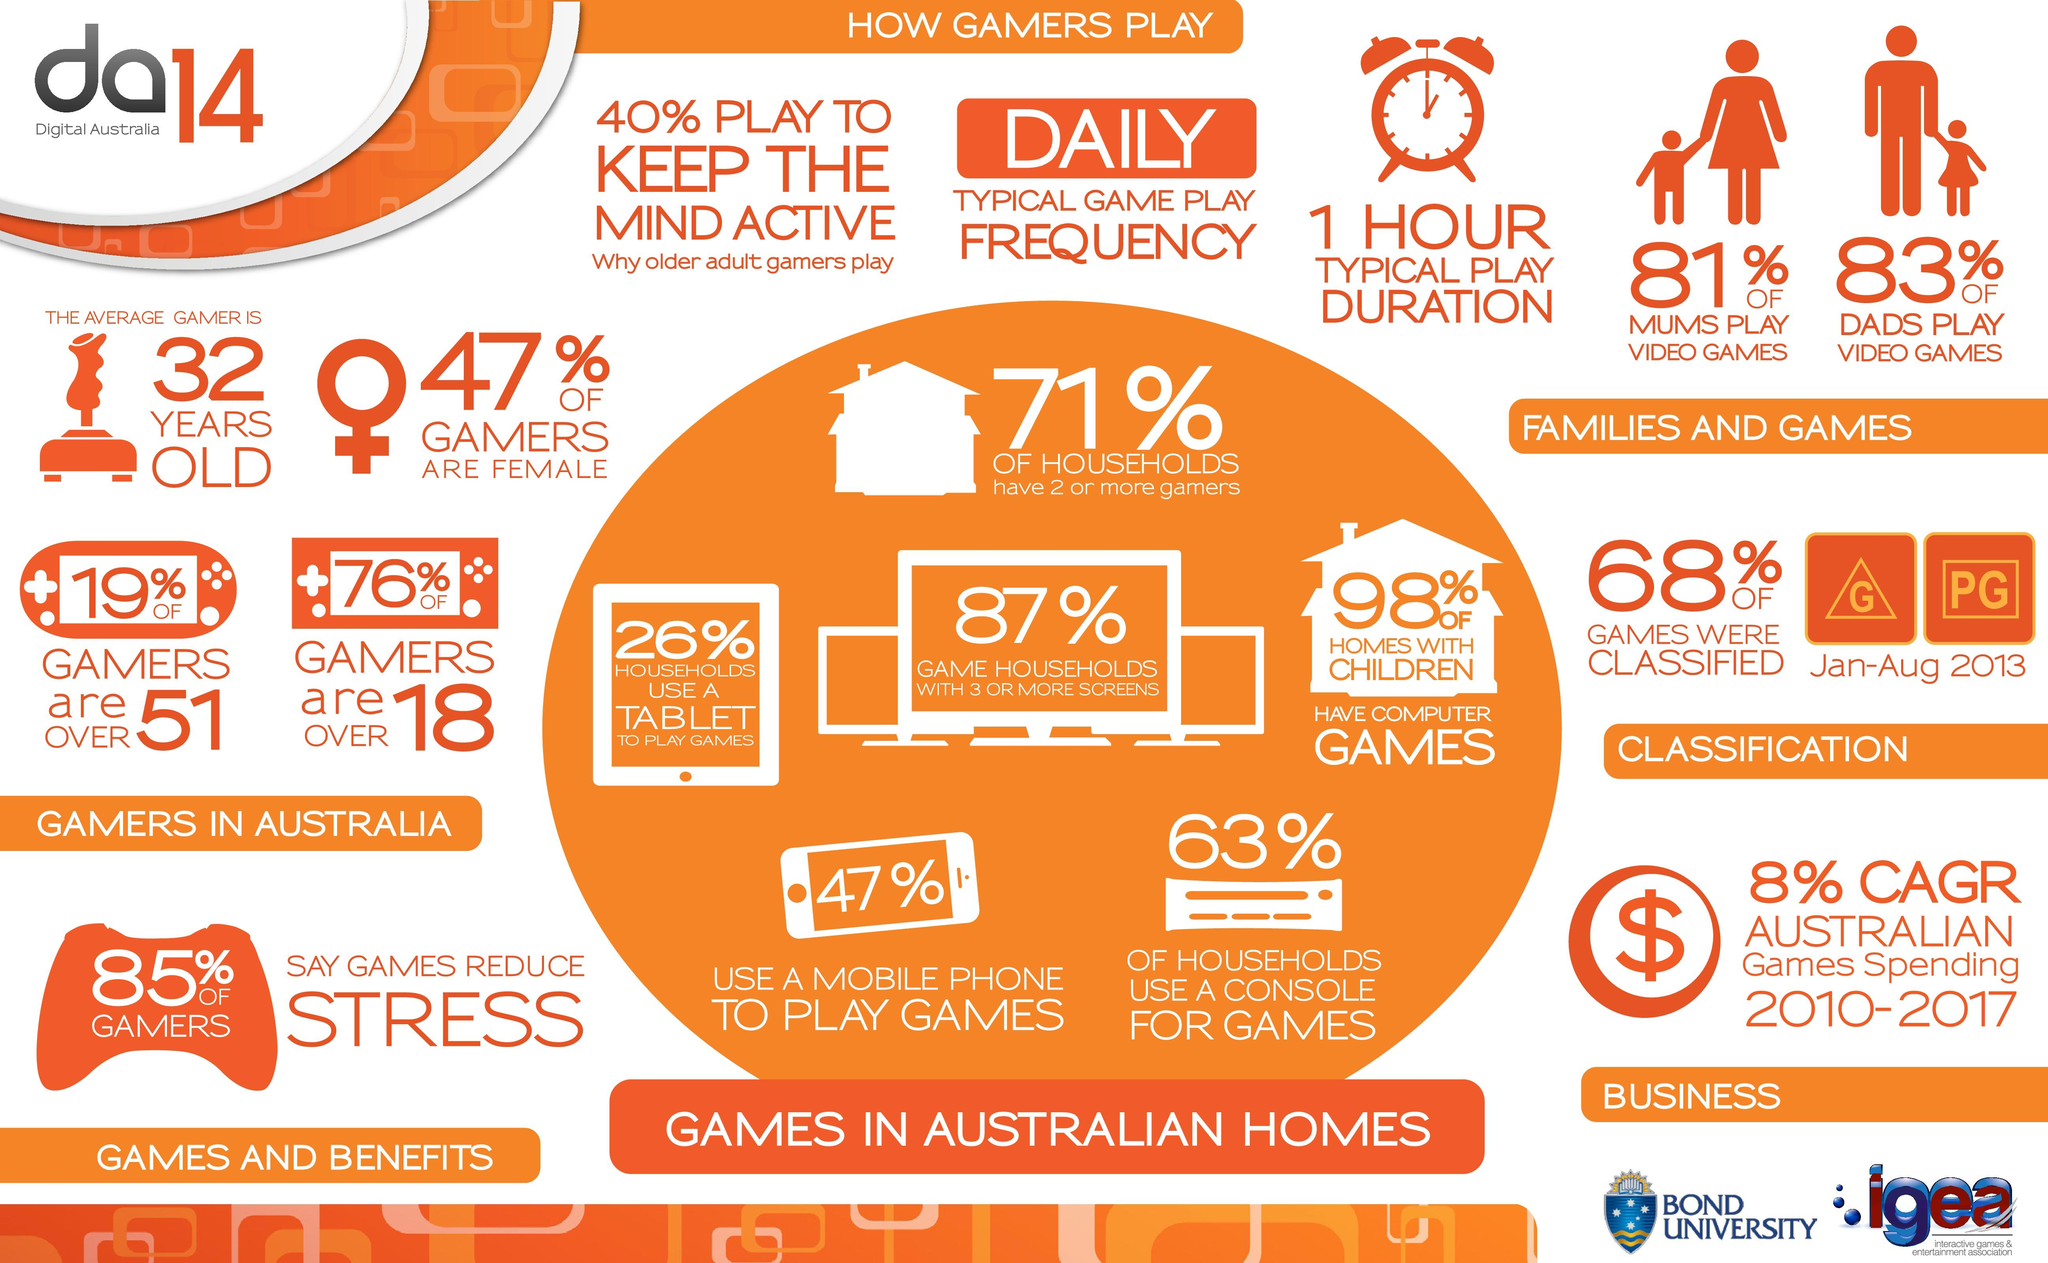Specify some key components in this picture. In 2014, it was found that 53% of gamers in Australia were male. In 2014, 47% of gamers in Australia used a mobile phone to play games. The average age of gamers in Australia in 2014 was 32 years old. In 2014, 26% of households in Australia used tablets to play games, according to a survey conducted that year. In 2014, only 2% of homes with children in Australia did not have computer games. 